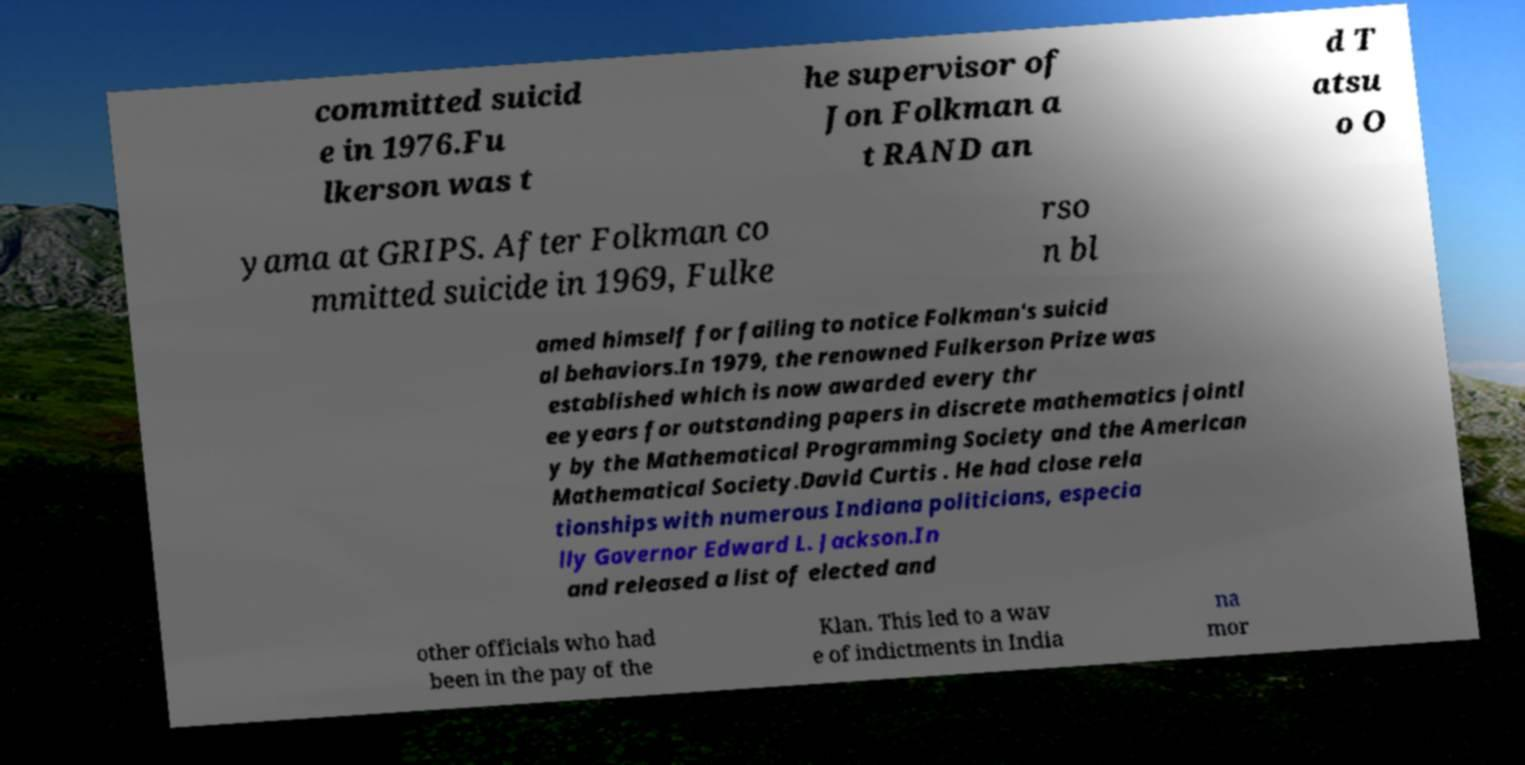Can you read and provide the text displayed in the image?This photo seems to have some interesting text. Can you extract and type it out for me? committed suicid e in 1976.Fu lkerson was t he supervisor of Jon Folkman a t RAND an d T atsu o O yama at GRIPS. After Folkman co mmitted suicide in 1969, Fulke rso n bl amed himself for failing to notice Folkman's suicid al behaviors.In 1979, the renowned Fulkerson Prize was established which is now awarded every thr ee years for outstanding papers in discrete mathematics jointl y by the Mathematical Programming Society and the American Mathematical Society.David Curtis . He had close rela tionships with numerous Indiana politicians, especia lly Governor Edward L. Jackson.In and released a list of elected and other officials who had been in the pay of the Klan. This led to a wav e of indictments in India na mor 